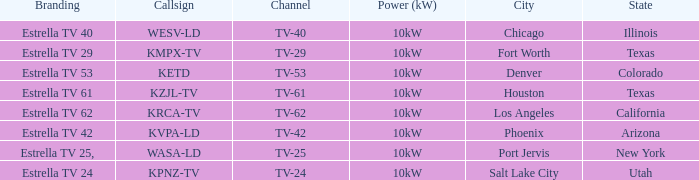Which city did kpnz-tv provide coverage for? Salt Lake City. 